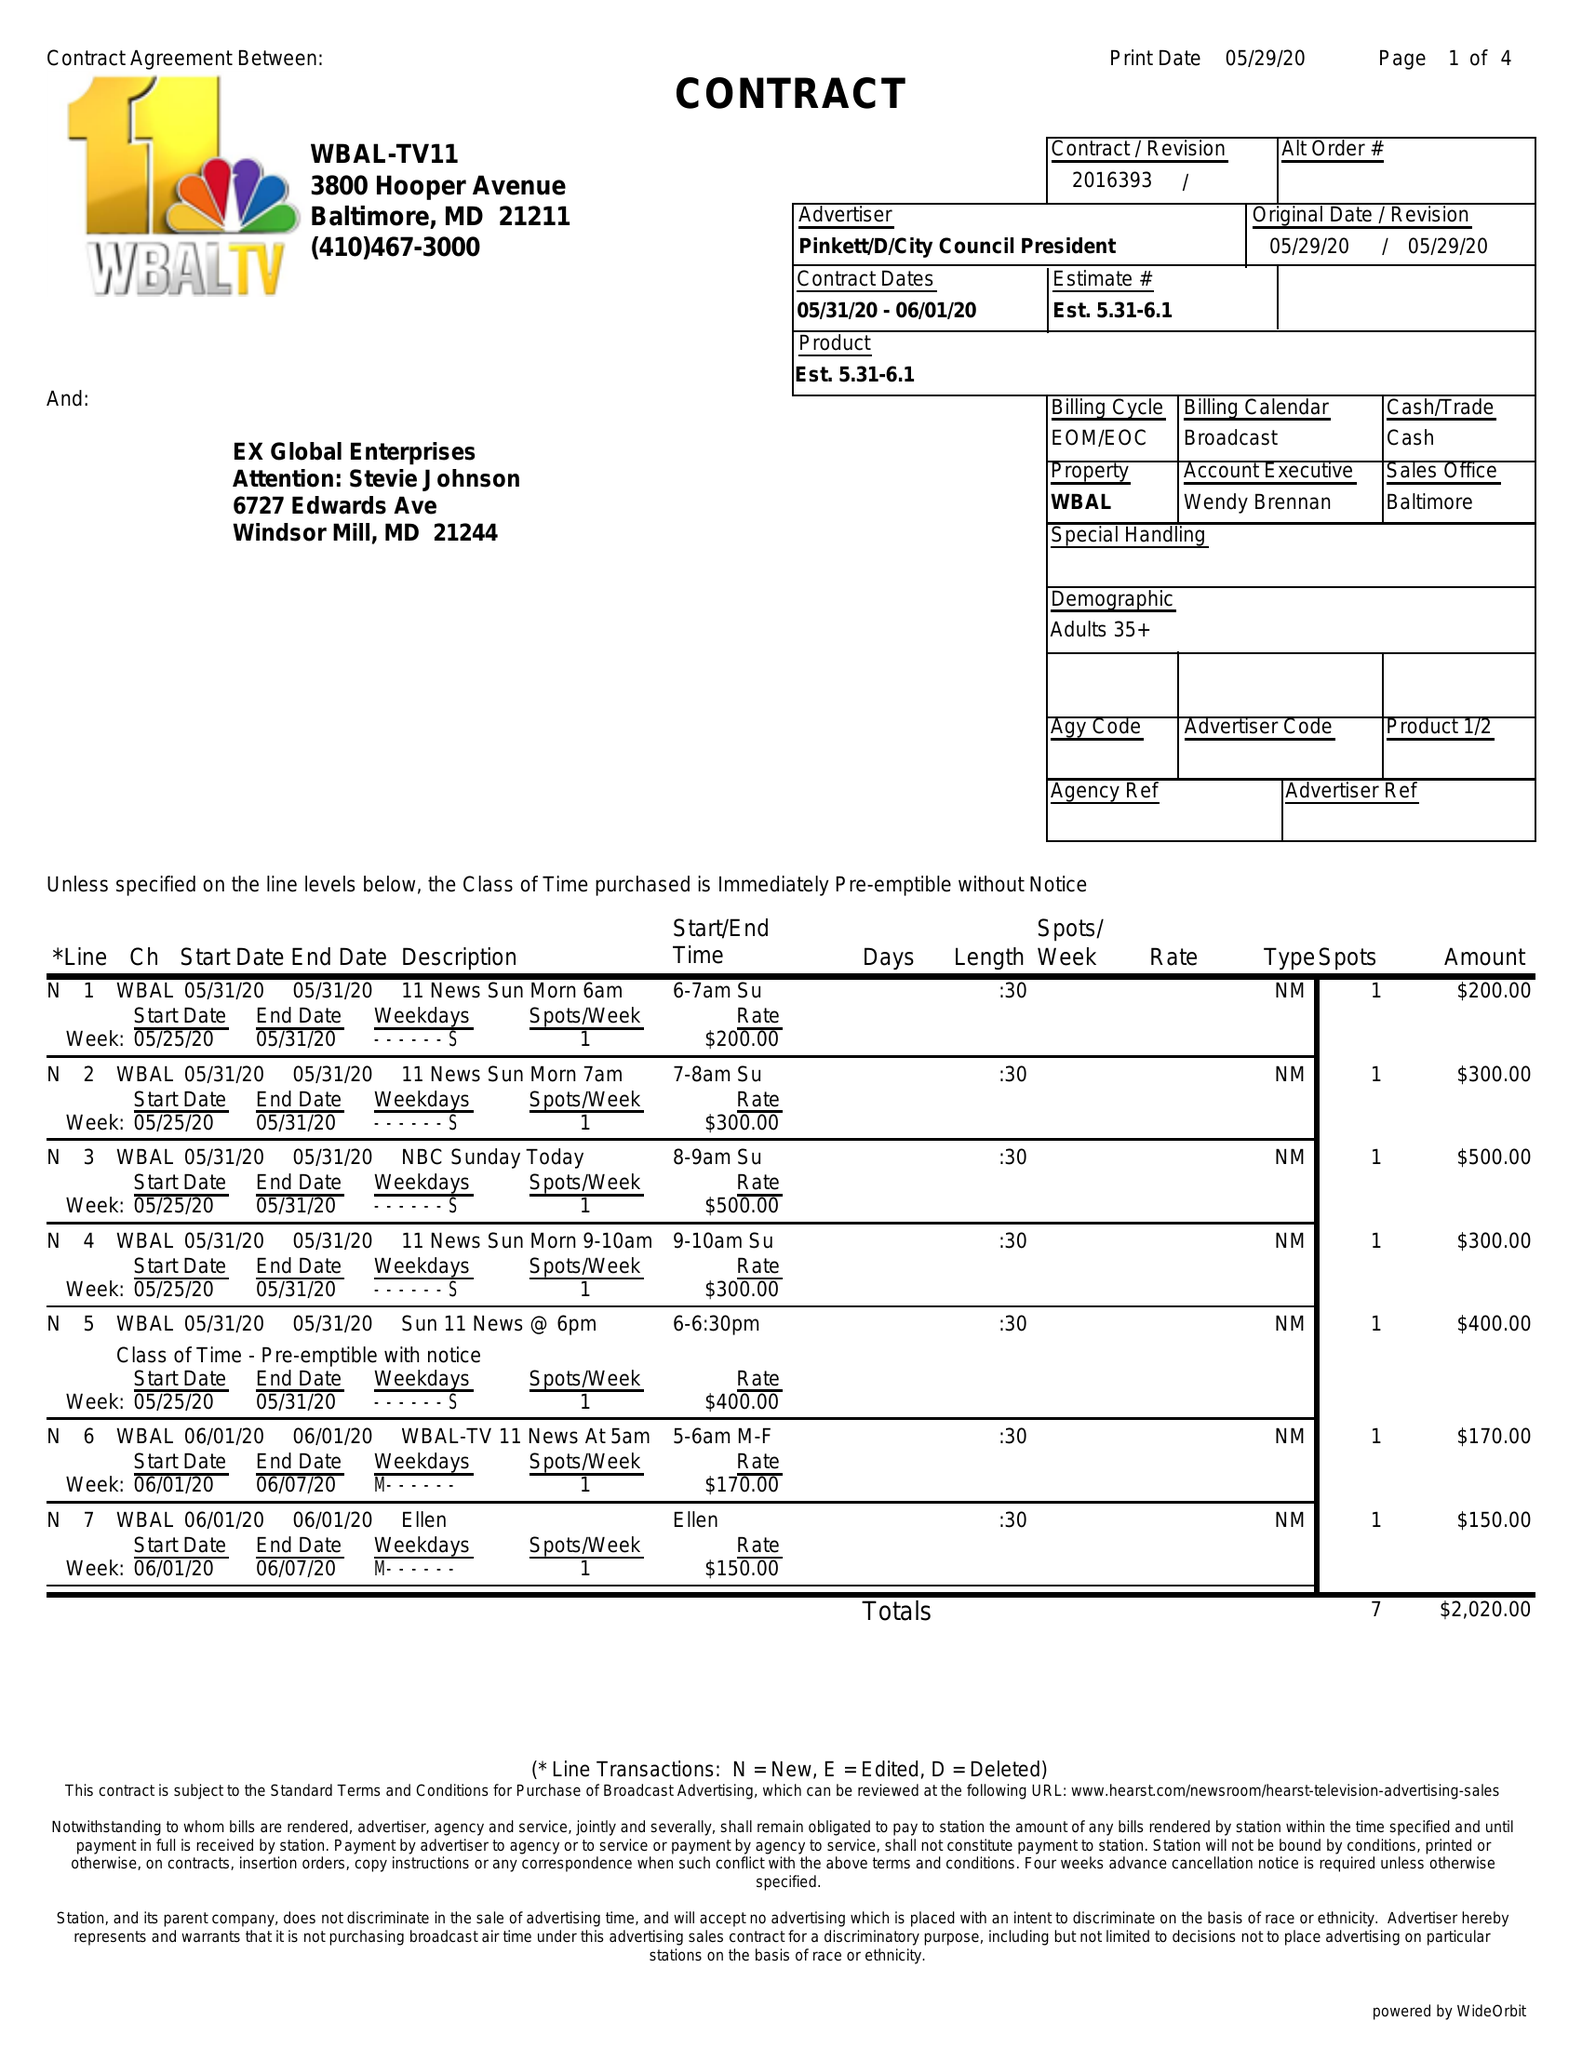What is the value for the gross_amount?
Answer the question using a single word or phrase. 2020.00 